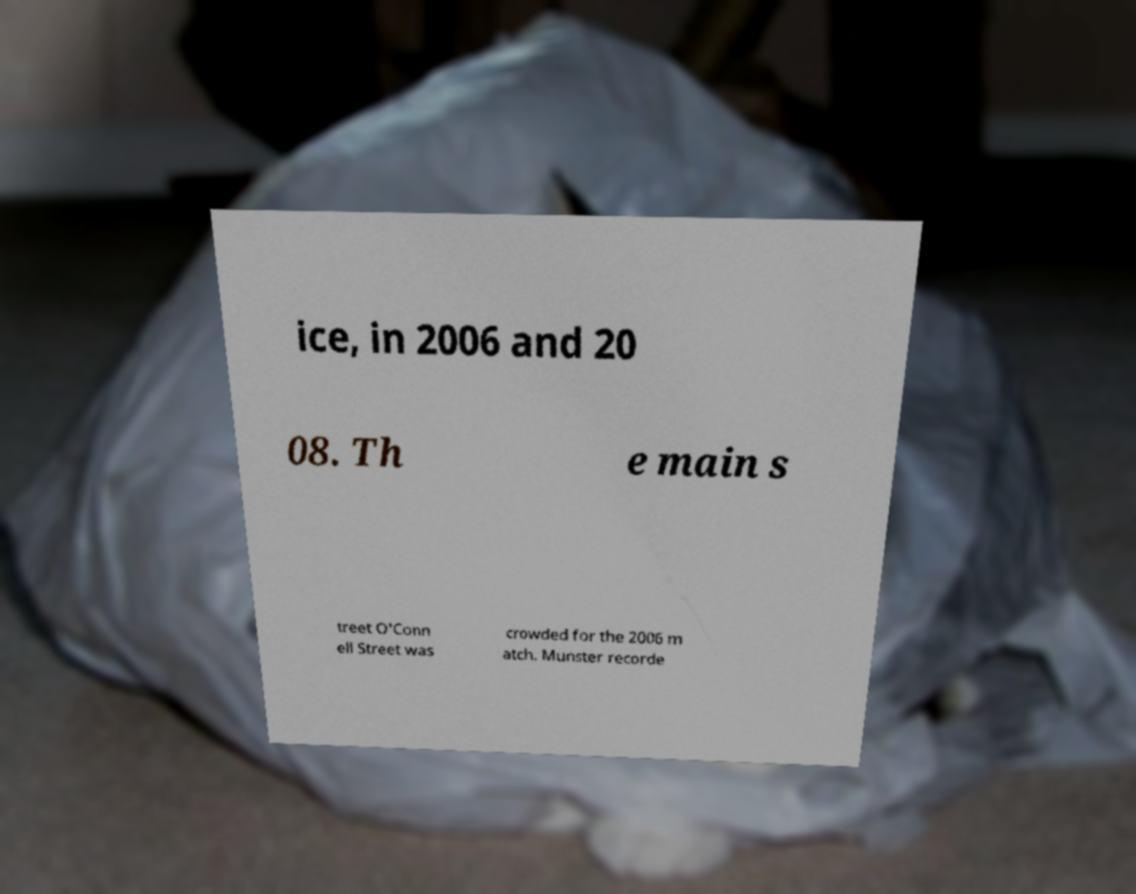Please read and relay the text visible in this image. What does it say? ice, in 2006 and 20 08. Th e main s treet O'Conn ell Street was crowded for the 2006 m atch. Munster recorde 